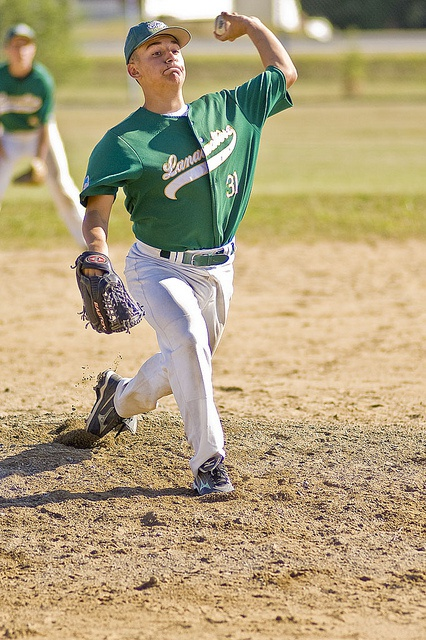Describe the objects in this image and their specific colors. I can see people in olive, darkgray, teal, white, and tan tones, people in olive, tan, darkgray, and white tones, baseball glove in olive, black, gray, and darkgray tones, and sports ball in olive, tan, and gray tones in this image. 